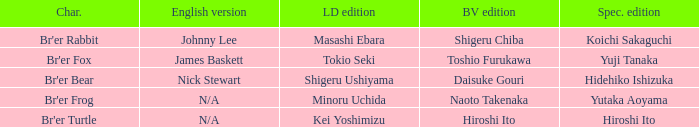Help me parse the entirety of this table. {'header': ['Char.', 'English version', 'LD edition', 'BV edition', 'Spec. edition'], 'rows': [["Br'er Rabbit", 'Johnny Lee', 'Masashi Ebara', 'Shigeru Chiba', 'Koichi Sakaguchi'], ["Br'er Fox", 'James Baskett', 'Tokio Seki', 'Toshio Furukawa', 'Yuji Tanaka'], ["Br'er Bear", 'Nick Stewart', 'Shigeru Ushiyama', 'Daisuke Gouri', 'Hidehiko Ishizuka'], ["Br'er Frog", 'N/A', 'Minoru Uchida', 'Naoto Takenaka', 'Yutaka Aoyama'], ["Br'er Turtle", 'N/A', 'Kei Yoshimizu', 'Hiroshi Ito', 'Hiroshi Ito']]} What is the english version that is buena vista edition is daisuke gouri? Nick Stewart. 